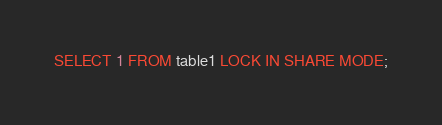Convert code to text. <code><loc_0><loc_0><loc_500><loc_500><_SQL_>SELECT 1 FROM table1 LOCK IN SHARE MODE;
</code> 